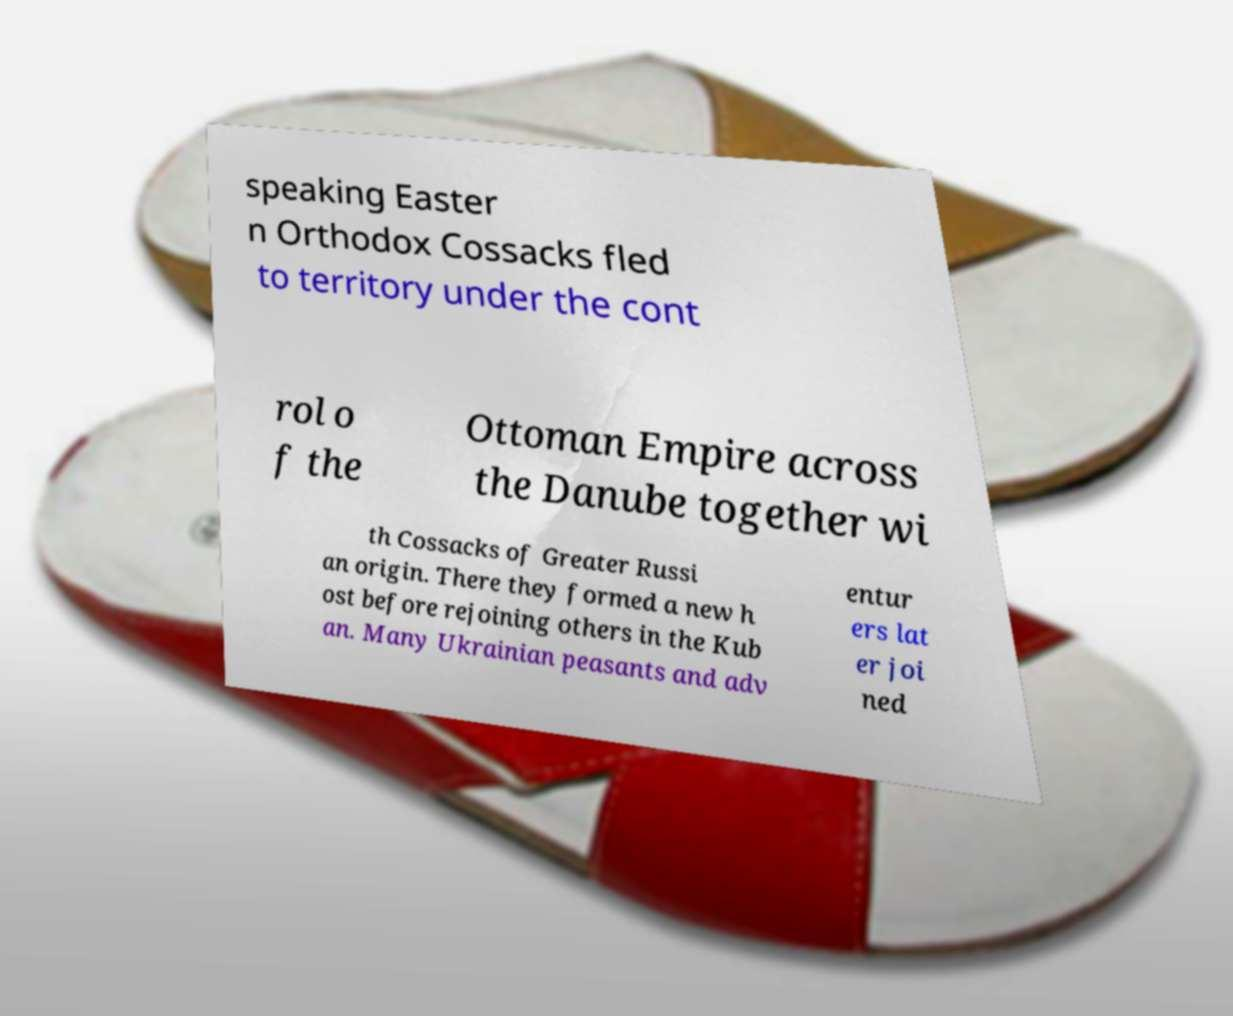Can you read and provide the text displayed in the image?This photo seems to have some interesting text. Can you extract and type it out for me? speaking Easter n Orthodox Cossacks fled to territory under the cont rol o f the Ottoman Empire across the Danube together wi th Cossacks of Greater Russi an origin. There they formed a new h ost before rejoining others in the Kub an. Many Ukrainian peasants and adv entur ers lat er joi ned 